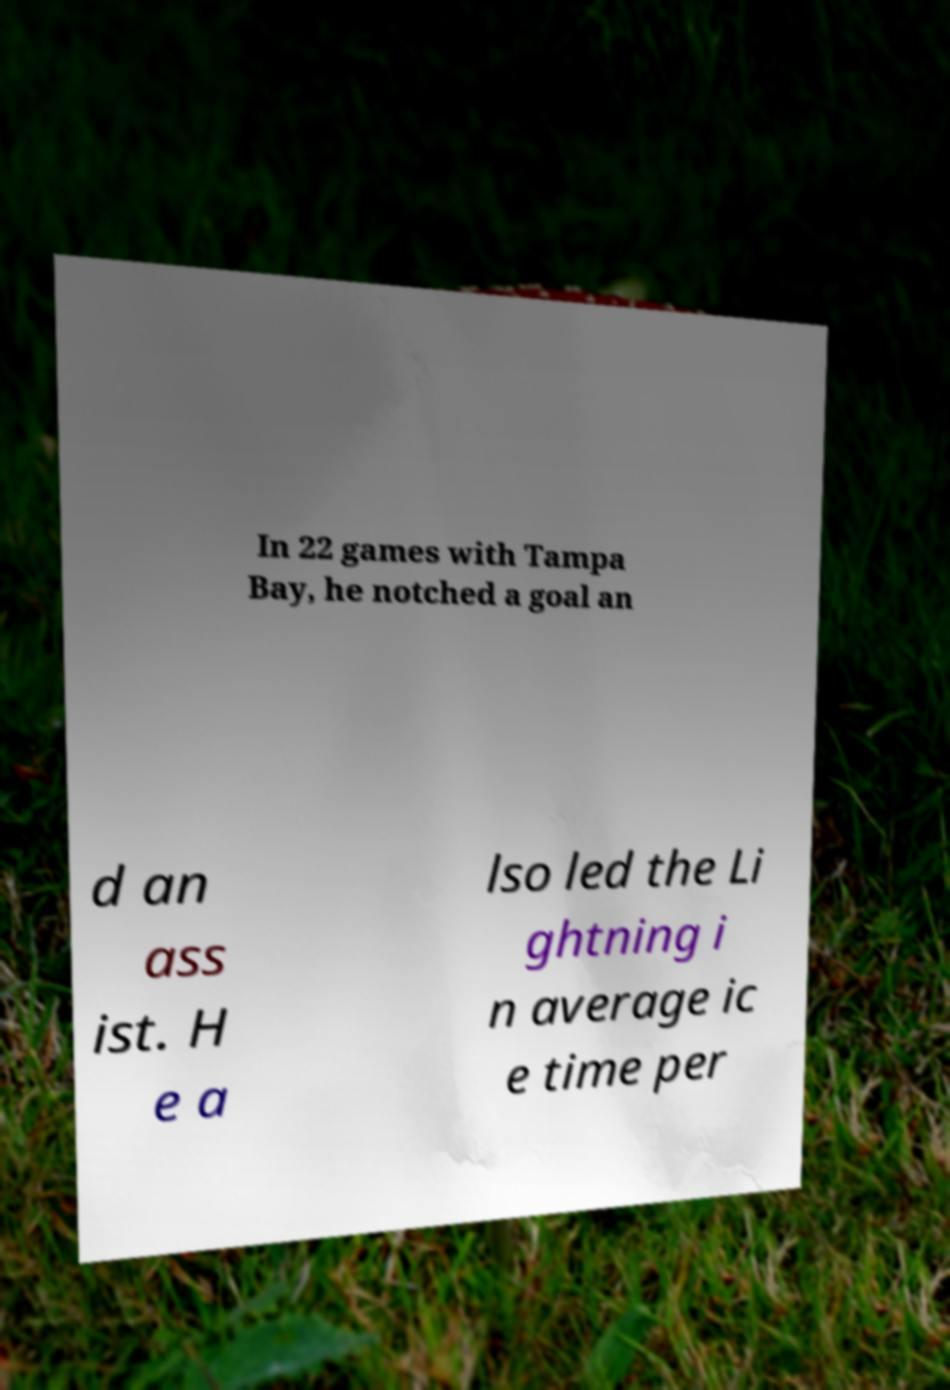Can you accurately transcribe the text from the provided image for me? In 22 games with Tampa Bay, he notched a goal an d an ass ist. H e a lso led the Li ghtning i n average ic e time per 